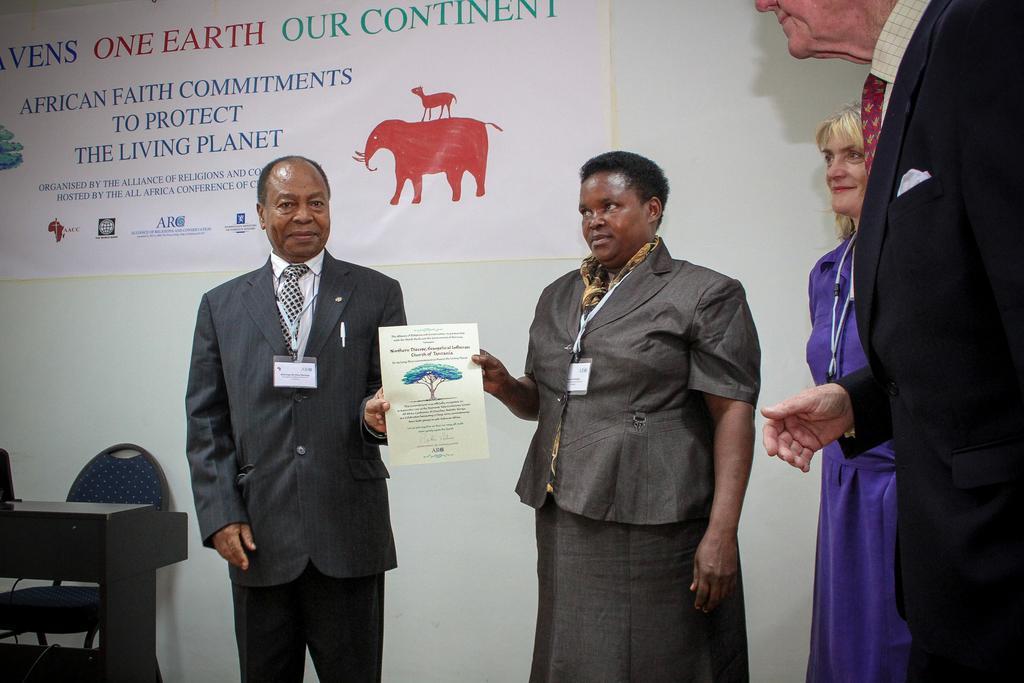Could you give a brief overview of what you see in this image? This picture consists of two persons in the middle standing in front the wall and they both are holding paper, on the wall there is pomp let attached, on the pom let I can see text and picture of animal. In the bottom there is a chair and table, on the right side there are two persons visible. 